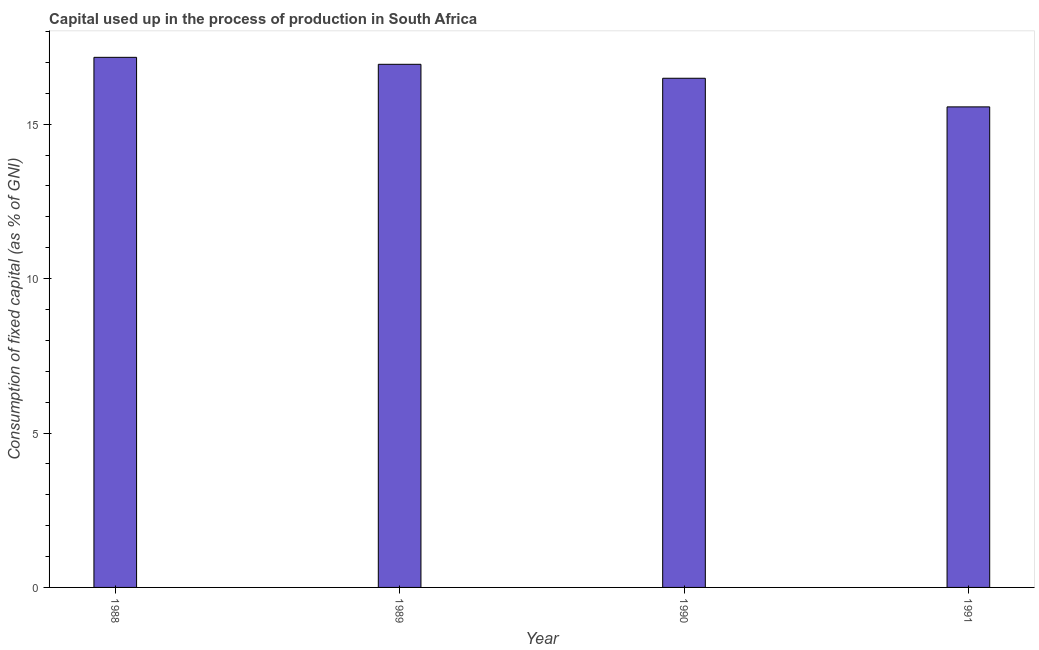What is the title of the graph?
Offer a very short reply. Capital used up in the process of production in South Africa. What is the label or title of the Y-axis?
Give a very brief answer. Consumption of fixed capital (as % of GNI). What is the consumption of fixed capital in 1990?
Your answer should be very brief. 16.49. Across all years, what is the maximum consumption of fixed capital?
Provide a succinct answer. 17.16. Across all years, what is the minimum consumption of fixed capital?
Keep it short and to the point. 15.56. In which year was the consumption of fixed capital maximum?
Your response must be concise. 1988. What is the sum of the consumption of fixed capital?
Offer a terse response. 66.15. What is the difference between the consumption of fixed capital in 1988 and 1990?
Your answer should be very brief. 0.68. What is the average consumption of fixed capital per year?
Provide a short and direct response. 16.54. What is the median consumption of fixed capital?
Your response must be concise. 16.71. What is the ratio of the consumption of fixed capital in 1989 to that in 1990?
Make the answer very short. 1.03. Is the difference between the consumption of fixed capital in 1989 and 1991 greater than the difference between any two years?
Your answer should be very brief. No. What is the difference between the highest and the second highest consumption of fixed capital?
Give a very brief answer. 0.23. How many bars are there?
Give a very brief answer. 4. Are all the bars in the graph horizontal?
Your response must be concise. No. What is the Consumption of fixed capital (as % of GNI) in 1988?
Offer a terse response. 17.16. What is the Consumption of fixed capital (as % of GNI) of 1989?
Your answer should be very brief. 16.94. What is the Consumption of fixed capital (as % of GNI) of 1990?
Your response must be concise. 16.49. What is the Consumption of fixed capital (as % of GNI) of 1991?
Your answer should be very brief. 15.56. What is the difference between the Consumption of fixed capital (as % of GNI) in 1988 and 1989?
Your response must be concise. 0.23. What is the difference between the Consumption of fixed capital (as % of GNI) in 1988 and 1990?
Keep it short and to the point. 0.68. What is the difference between the Consumption of fixed capital (as % of GNI) in 1988 and 1991?
Provide a succinct answer. 1.6. What is the difference between the Consumption of fixed capital (as % of GNI) in 1989 and 1990?
Your answer should be compact. 0.45. What is the difference between the Consumption of fixed capital (as % of GNI) in 1989 and 1991?
Your answer should be very brief. 1.38. What is the difference between the Consumption of fixed capital (as % of GNI) in 1990 and 1991?
Make the answer very short. 0.93. What is the ratio of the Consumption of fixed capital (as % of GNI) in 1988 to that in 1989?
Make the answer very short. 1.01. What is the ratio of the Consumption of fixed capital (as % of GNI) in 1988 to that in 1990?
Provide a short and direct response. 1.04. What is the ratio of the Consumption of fixed capital (as % of GNI) in 1988 to that in 1991?
Offer a terse response. 1.1. What is the ratio of the Consumption of fixed capital (as % of GNI) in 1989 to that in 1990?
Give a very brief answer. 1.03. What is the ratio of the Consumption of fixed capital (as % of GNI) in 1989 to that in 1991?
Offer a terse response. 1.09. What is the ratio of the Consumption of fixed capital (as % of GNI) in 1990 to that in 1991?
Provide a short and direct response. 1.06. 